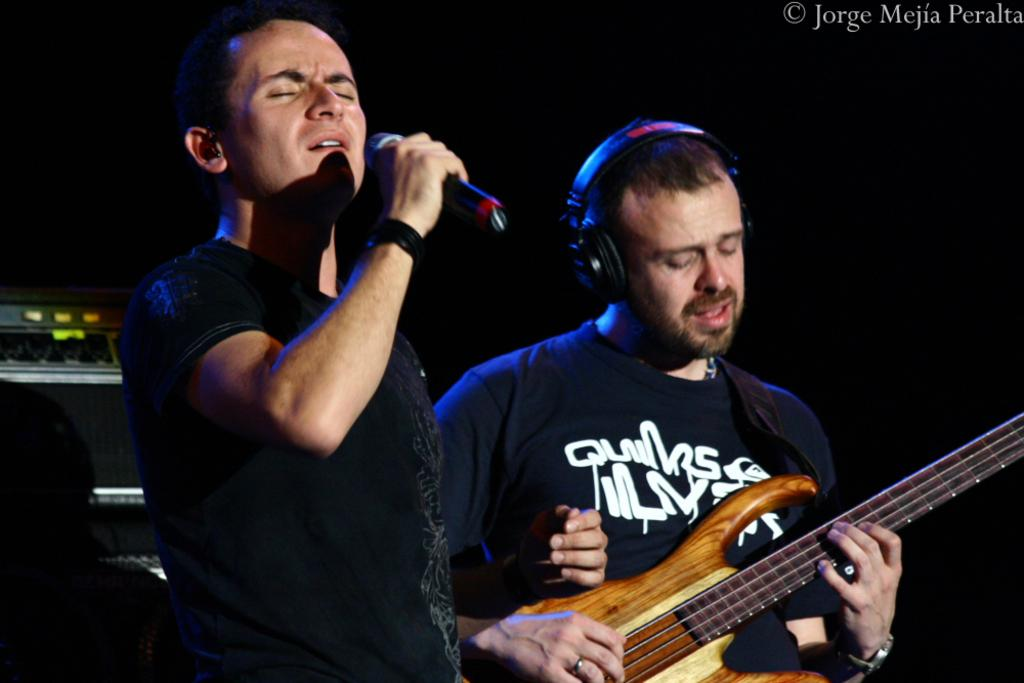How many people are in the image? There are two persons in the image. Where is the person on the left side located? The person on the left side is on the left side of the image. What is the person on the left side doing? The person on the left side is singing into a microphone. Where is the person on the right side located? The person on the right side is on the right side of the image. What is the person on the right side holding? The person on the right side is holding a guitar. What is the person on the right side doing with the guitar? The person on the right side is playing the guitar. What is the person on the right side wearing? The person on the right side is wearing headphones. What type of music is bursting out of the guitar in the image? There is no indication in the image that the guitar is bursting or producing any music; it is being played by the person on the right side. 